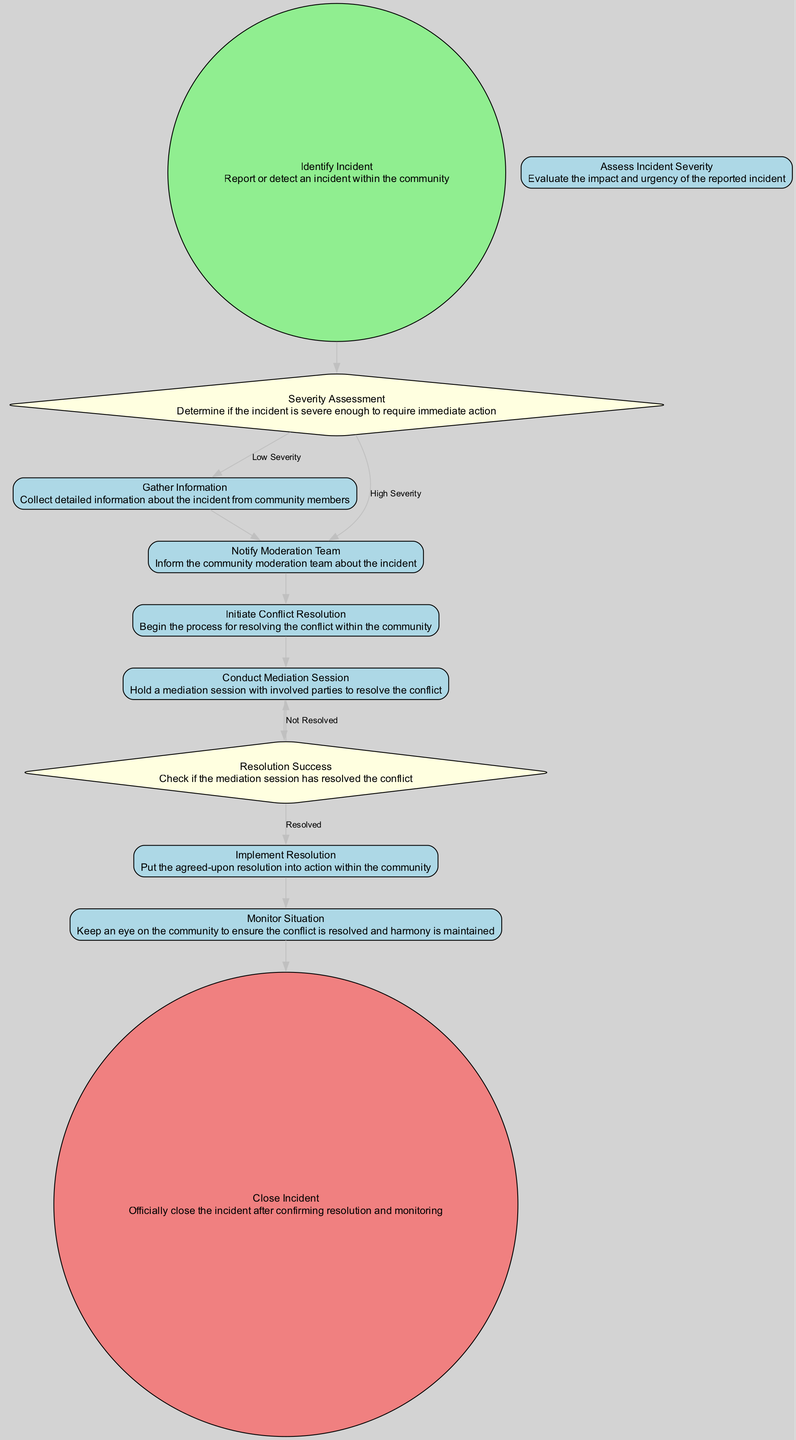What is the first activity in the diagram? The first activity is labeled "Identify Incident," and it starts the process of incident handling by reporting or detecting an incident.
Answer: Identify Incident How many activities are shown in the diagram? By counting the activities listed in the data provided, including both start and end events, there are a total of eight activities.
Answer: Eight What decision leads to the "Notify Moderation Team"? There are two paths leading to "Notify Moderation Team": one is from "Severity Assessment" if the severity is High, and the other is from "Gather Information." This means that both a high severity assessment or gathering information can lead to notifying the team.
Answer: High Severity, Gather Information What activity follows "Conduct Mediation Session"? From analyzing the flow, the activity that directly follows "Conduct Mediation Session" is "Resolution Success," which determines if the mediation has resolved the conflict.
Answer: Resolution Success What happens if the resolution is "Not Resolved"? If the resolution is "Not Resolved," the flow indicates that it goes back to "Conduct Mediation Session," meaning that additional mediation is required to address the conflict.
Answer: Conduct Mediation Session How does the "Monitor Situation" activity contribute to closing the incident? "Monitor Situation" is crucial because it involves keeping an eye on the community to ensure that the conflict is effectively resolved, and only after monitoring can the incident be officially closed.
Answer: Ensures resolution Which activity serves as the end point of the incident handling process? The end point of the process is "Close Incident," which signifies the official closure after confirming resolution and monitoring, thereby concluding the incident.
Answer: Close Incident What is the purpose of the "Gather Information" activity? The purpose of "Gather Information" is to collect detailed information about the incident from community members, which is essential for assessing the situation effectively.
Answer: Collect detailed information How many decision branches are included in the diagram? There are two decision branches present in the diagram: one for "Severity Assessment" and another for "Resolution Success," indicating different paths based on outcomes of those assessments.
Answer: Two 